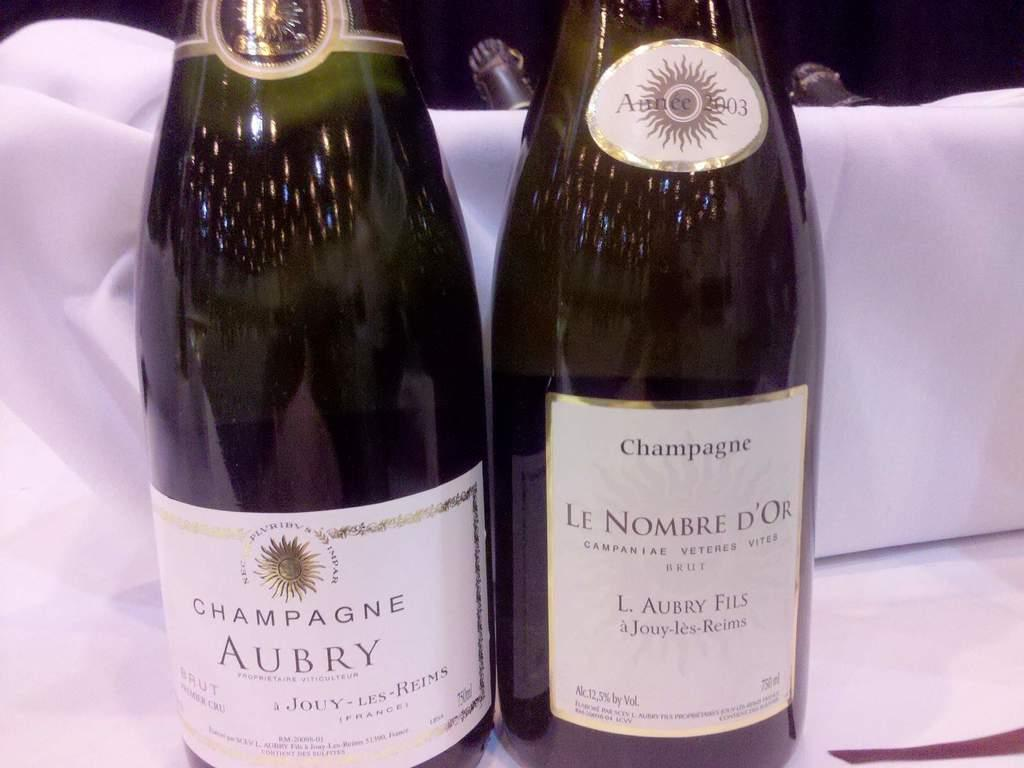<image>
Present a compact description of the photo's key features. an aubry label that is on a bottle 